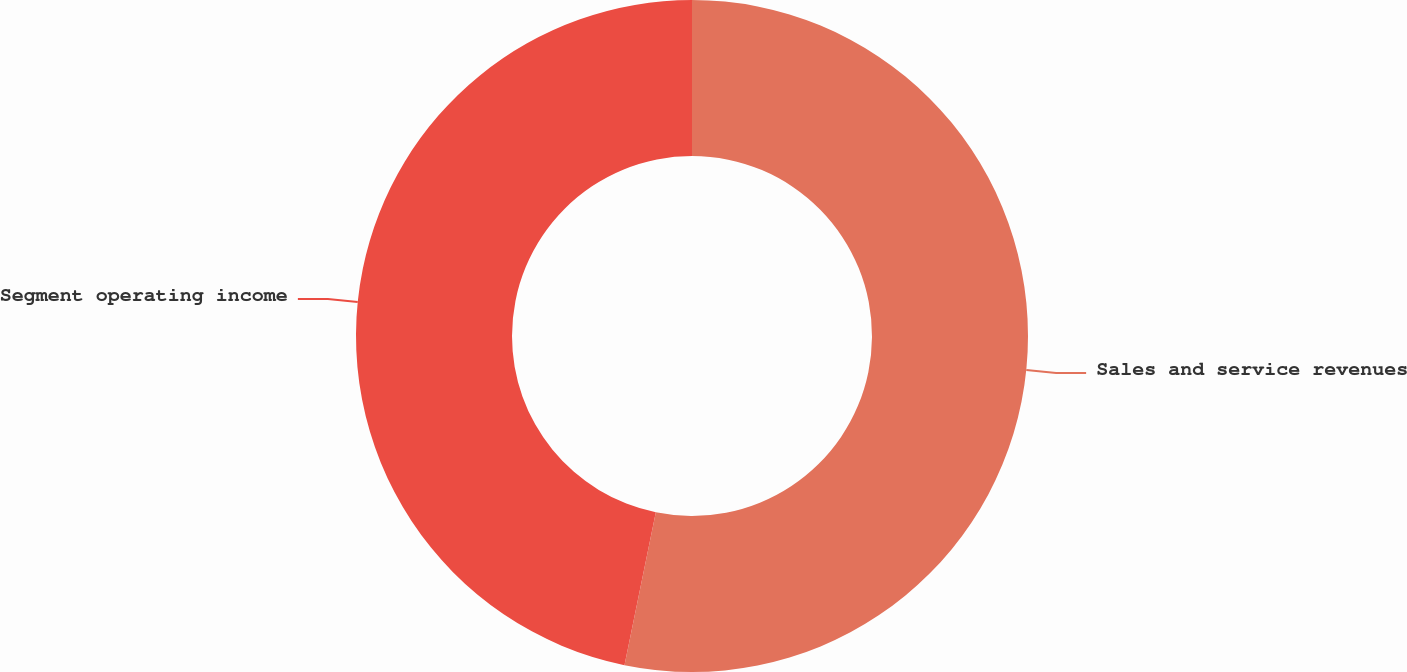Convert chart. <chart><loc_0><loc_0><loc_500><loc_500><pie_chart><fcel>Sales and service revenues<fcel>Segment operating income<nl><fcel>53.22%<fcel>46.78%<nl></chart> 